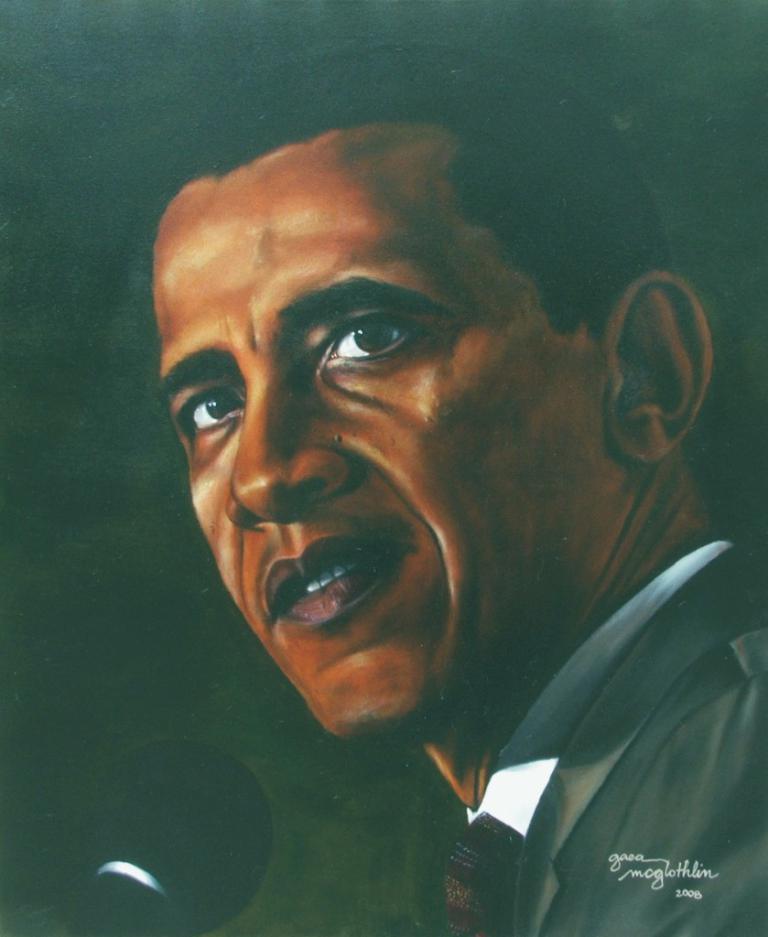Please provide a concise description of this image. It is a painting. This painting contains a mic and text written on it. The person in this painting is known as Obama, he wear white shirt with tie and coat. 